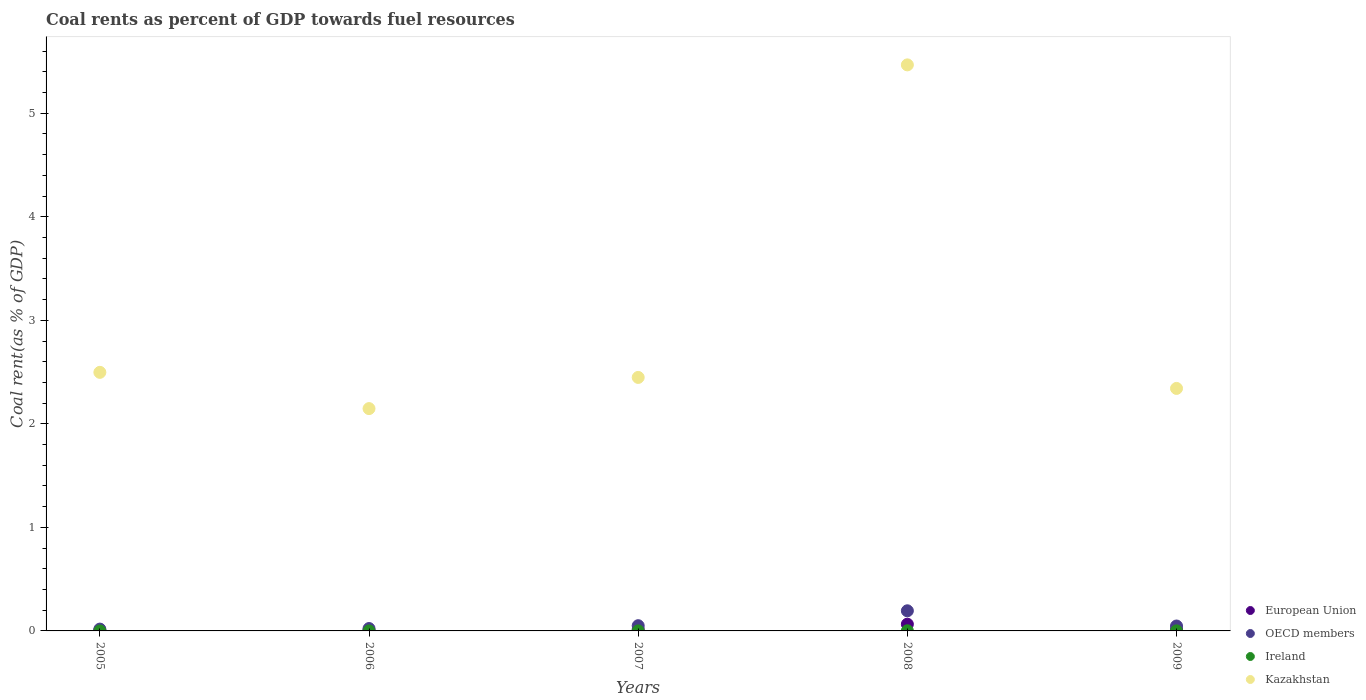What is the coal rent in Kazakhstan in 2007?
Your answer should be very brief. 2.45. Across all years, what is the maximum coal rent in Ireland?
Your response must be concise. 0. Across all years, what is the minimum coal rent in European Union?
Your answer should be very brief. 0.01. What is the total coal rent in Kazakhstan in the graph?
Ensure brevity in your answer.  14.9. What is the difference between the coal rent in European Union in 2006 and that in 2008?
Offer a terse response. -0.06. What is the difference between the coal rent in Ireland in 2005 and the coal rent in OECD members in 2008?
Your answer should be compact. -0.19. What is the average coal rent in European Union per year?
Your answer should be compact. 0.02. In the year 2006, what is the difference between the coal rent in OECD members and coal rent in European Union?
Your response must be concise. 0.02. In how many years, is the coal rent in Ireland greater than 1.8 %?
Provide a short and direct response. 0. What is the ratio of the coal rent in OECD members in 2008 to that in 2009?
Offer a very short reply. 4.09. Is the coal rent in Ireland in 2005 less than that in 2007?
Ensure brevity in your answer.  Yes. What is the difference between the highest and the second highest coal rent in OECD members?
Provide a succinct answer. 0.14. What is the difference between the highest and the lowest coal rent in Ireland?
Provide a short and direct response. 0. Is it the case that in every year, the sum of the coal rent in OECD members and coal rent in Kazakhstan  is greater than the sum of coal rent in European Union and coal rent in Ireland?
Make the answer very short. Yes. Is the coal rent in OECD members strictly greater than the coal rent in Ireland over the years?
Your answer should be compact. Yes. Is the coal rent in OECD members strictly less than the coal rent in Ireland over the years?
Give a very brief answer. No. How many dotlines are there?
Your answer should be compact. 4. What is the difference between two consecutive major ticks on the Y-axis?
Make the answer very short. 1. Are the values on the major ticks of Y-axis written in scientific E-notation?
Keep it short and to the point. No. Does the graph contain any zero values?
Offer a terse response. No. Does the graph contain grids?
Keep it short and to the point. No. How many legend labels are there?
Offer a very short reply. 4. How are the legend labels stacked?
Provide a succinct answer. Vertical. What is the title of the graph?
Ensure brevity in your answer.  Coal rents as percent of GDP towards fuel resources. Does "South Sudan" appear as one of the legend labels in the graph?
Your response must be concise. No. What is the label or title of the Y-axis?
Keep it short and to the point. Coal rent(as % of GDP). What is the Coal rent(as % of GDP) of European Union in 2005?
Make the answer very short. 0.01. What is the Coal rent(as % of GDP) in OECD members in 2005?
Your answer should be very brief. 0.02. What is the Coal rent(as % of GDP) of Ireland in 2005?
Keep it short and to the point. 7.66717495498807e-5. What is the Coal rent(as % of GDP) of Kazakhstan in 2005?
Your answer should be compact. 2.5. What is the Coal rent(as % of GDP) of European Union in 2006?
Your answer should be very brief. 0.01. What is the Coal rent(as % of GDP) in OECD members in 2006?
Make the answer very short. 0.02. What is the Coal rent(as % of GDP) in Ireland in 2006?
Keep it short and to the point. 0. What is the Coal rent(as % of GDP) of Kazakhstan in 2006?
Offer a terse response. 2.15. What is the Coal rent(as % of GDP) of European Union in 2007?
Provide a succinct answer. 0.01. What is the Coal rent(as % of GDP) in OECD members in 2007?
Provide a short and direct response. 0.05. What is the Coal rent(as % of GDP) of Ireland in 2007?
Your response must be concise. 0. What is the Coal rent(as % of GDP) in Kazakhstan in 2007?
Your answer should be compact. 2.45. What is the Coal rent(as % of GDP) in European Union in 2008?
Ensure brevity in your answer.  0.07. What is the Coal rent(as % of GDP) of OECD members in 2008?
Provide a short and direct response. 0.19. What is the Coal rent(as % of GDP) in Ireland in 2008?
Ensure brevity in your answer.  0. What is the Coal rent(as % of GDP) in Kazakhstan in 2008?
Make the answer very short. 5.47. What is the Coal rent(as % of GDP) of European Union in 2009?
Ensure brevity in your answer.  0.01. What is the Coal rent(as % of GDP) of OECD members in 2009?
Offer a very short reply. 0.05. What is the Coal rent(as % of GDP) in Ireland in 2009?
Your response must be concise. 0. What is the Coal rent(as % of GDP) of Kazakhstan in 2009?
Your answer should be very brief. 2.34. Across all years, what is the maximum Coal rent(as % of GDP) of European Union?
Make the answer very short. 0.07. Across all years, what is the maximum Coal rent(as % of GDP) in OECD members?
Offer a terse response. 0.19. Across all years, what is the maximum Coal rent(as % of GDP) in Ireland?
Your answer should be compact. 0. Across all years, what is the maximum Coal rent(as % of GDP) of Kazakhstan?
Your answer should be compact. 5.47. Across all years, what is the minimum Coal rent(as % of GDP) in European Union?
Keep it short and to the point. 0.01. Across all years, what is the minimum Coal rent(as % of GDP) in OECD members?
Keep it short and to the point. 0.02. Across all years, what is the minimum Coal rent(as % of GDP) in Ireland?
Give a very brief answer. 7.66717495498807e-5. Across all years, what is the minimum Coal rent(as % of GDP) of Kazakhstan?
Provide a short and direct response. 2.15. What is the total Coal rent(as % of GDP) of European Union in the graph?
Ensure brevity in your answer.  0.11. What is the total Coal rent(as % of GDP) in OECD members in the graph?
Offer a very short reply. 0.33. What is the total Coal rent(as % of GDP) of Ireland in the graph?
Provide a succinct answer. 0. What is the total Coal rent(as % of GDP) in Kazakhstan in the graph?
Offer a very short reply. 14.9. What is the difference between the Coal rent(as % of GDP) of European Union in 2005 and that in 2006?
Ensure brevity in your answer.  -0. What is the difference between the Coal rent(as % of GDP) of OECD members in 2005 and that in 2006?
Your answer should be compact. -0.01. What is the difference between the Coal rent(as % of GDP) of Ireland in 2005 and that in 2006?
Offer a terse response. -0. What is the difference between the Coal rent(as % of GDP) of Kazakhstan in 2005 and that in 2006?
Offer a very short reply. 0.35. What is the difference between the Coal rent(as % of GDP) of European Union in 2005 and that in 2007?
Provide a succinct answer. -0.01. What is the difference between the Coal rent(as % of GDP) of OECD members in 2005 and that in 2007?
Your answer should be compact. -0.03. What is the difference between the Coal rent(as % of GDP) in Ireland in 2005 and that in 2007?
Your answer should be very brief. -0. What is the difference between the Coal rent(as % of GDP) in Kazakhstan in 2005 and that in 2007?
Provide a short and direct response. 0.05. What is the difference between the Coal rent(as % of GDP) in European Union in 2005 and that in 2008?
Offer a very short reply. -0.06. What is the difference between the Coal rent(as % of GDP) of OECD members in 2005 and that in 2008?
Offer a very short reply. -0.18. What is the difference between the Coal rent(as % of GDP) in Ireland in 2005 and that in 2008?
Your response must be concise. -0. What is the difference between the Coal rent(as % of GDP) in Kazakhstan in 2005 and that in 2008?
Provide a succinct answer. -2.97. What is the difference between the Coal rent(as % of GDP) in European Union in 2005 and that in 2009?
Your answer should be very brief. -0.01. What is the difference between the Coal rent(as % of GDP) of OECD members in 2005 and that in 2009?
Give a very brief answer. -0.03. What is the difference between the Coal rent(as % of GDP) in Ireland in 2005 and that in 2009?
Make the answer very short. -0. What is the difference between the Coal rent(as % of GDP) of Kazakhstan in 2005 and that in 2009?
Offer a very short reply. 0.16. What is the difference between the Coal rent(as % of GDP) in European Union in 2006 and that in 2007?
Give a very brief answer. -0.01. What is the difference between the Coal rent(as % of GDP) of OECD members in 2006 and that in 2007?
Offer a terse response. -0.03. What is the difference between the Coal rent(as % of GDP) of Ireland in 2006 and that in 2007?
Provide a succinct answer. -0. What is the difference between the Coal rent(as % of GDP) in Kazakhstan in 2006 and that in 2007?
Give a very brief answer. -0.3. What is the difference between the Coal rent(as % of GDP) in European Union in 2006 and that in 2008?
Provide a succinct answer. -0.06. What is the difference between the Coal rent(as % of GDP) of OECD members in 2006 and that in 2008?
Make the answer very short. -0.17. What is the difference between the Coal rent(as % of GDP) of Ireland in 2006 and that in 2008?
Your answer should be compact. -0. What is the difference between the Coal rent(as % of GDP) in Kazakhstan in 2006 and that in 2008?
Offer a very short reply. -3.32. What is the difference between the Coal rent(as % of GDP) in European Union in 2006 and that in 2009?
Keep it short and to the point. -0.01. What is the difference between the Coal rent(as % of GDP) in OECD members in 2006 and that in 2009?
Your answer should be compact. -0.02. What is the difference between the Coal rent(as % of GDP) of Ireland in 2006 and that in 2009?
Your answer should be very brief. -0. What is the difference between the Coal rent(as % of GDP) of Kazakhstan in 2006 and that in 2009?
Your response must be concise. -0.19. What is the difference between the Coal rent(as % of GDP) of European Union in 2007 and that in 2008?
Give a very brief answer. -0.05. What is the difference between the Coal rent(as % of GDP) of OECD members in 2007 and that in 2008?
Your answer should be very brief. -0.14. What is the difference between the Coal rent(as % of GDP) of Ireland in 2007 and that in 2008?
Ensure brevity in your answer.  -0. What is the difference between the Coal rent(as % of GDP) in Kazakhstan in 2007 and that in 2008?
Your answer should be compact. -3.02. What is the difference between the Coal rent(as % of GDP) of European Union in 2007 and that in 2009?
Provide a short and direct response. 0. What is the difference between the Coal rent(as % of GDP) of OECD members in 2007 and that in 2009?
Provide a short and direct response. 0. What is the difference between the Coal rent(as % of GDP) of Ireland in 2007 and that in 2009?
Make the answer very short. -0. What is the difference between the Coal rent(as % of GDP) of Kazakhstan in 2007 and that in 2009?
Provide a succinct answer. 0.11. What is the difference between the Coal rent(as % of GDP) in European Union in 2008 and that in 2009?
Make the answer very short. 0.05. What is the difference between the Coal rent(as % of GDP) in OECD members in 2008 and that in 2009?
Offer a very short reply. 0.15. What is the difference between the Coal rent(as % of GDP) in Ireland in 2008 and that in 2009?
Offer a very short reply. 0. What is the difference between the Coal rent(as % of GDP) in Kazakhstan in 2008 and that in 2009?
Offer a terse response. 3.12. What is the difference between the Coal rent(as % of GDP) of European Union in 2005 and the Coal rent(as % of GDP) of OECD members in 2006?
Offer a terse response. -0.02. What is the difference between the Coal rent(as % of GDP) in European Union in 2005 and the Coal rent(as % of GDP) in Ireland in 2006?
Keep it short and to the point. 0.01. What is the difference between the Coal rent(as % of GDP) in European Union in 2005 and the Coal rent(as % of GDP) in Kazakhstan in 2006?
Keep it short and to the point. -2.14. What is the difference between the Coal rent(as % of GDP) in OECD members in 2005 and the Coal rent(as % of GDP) in Ireland in 2006?
Your response must be concise. 0.02. What is the difference between the Coal rent(as % of GDP) of OECD members in 2005 and the Coal rent(as % of GDP) of Kazakhstan in 2006?
Your answer should be compact. -2.13. What is the difference between the Coal rent(as % of GDP) of Ireland in 2005 and the Coal rent(as % of GDP) of Kazakhstan in 2006?
Offer a very short reply. -2.15. What is the difference between the Coal rent(as % of GDP) in European Union in 2005 and the Coal rent(as % of GDP) in OECD members in 2007?
Provide a succinct answer. -0.04. What is the difference between the Coal rent(as % of GDP) of European Union in 2005 and the Coal rent(as % of GDP) of Ireland in 2007?
Provide a short and direct response. 0.01. What is the difference between the Coal rent(as % of GDP) in European Union in 2005 and the Coal rent(as % of GDP) in Kazakhstan in 2007?
Keep it short and to the point. -2.44. What is the difference between the Coal rent(as % of GDP) in OECD members in 2005 and the Coal rent(as % of GDP) in Ireland in 2007?
Provide a short and direct response. 0.02. What is the difference between the Coal rent(as % of GDP) of OECD members in 2005 and the Coal rent(as % of GDP) of Kazakhstan in 2007?
Offer a very short reply. -2.43. What is the difference between the Coal rent(as % of GDP) in Ireland in 2005 and the Coal rent(as % of GDP) in Kazakhstan in 2007?
Your answer should be compact. -2.45. What is the difference between the Coal rent(as % of GDP) of European Union in 2005 and the Coal rent(as % of GDP) of OECD members in 2008?
Your answer should be very brief. -0.19. What is the difference between the Coal rent(as % of GDP) of European Union in 2005 and the Coal rent(as % of GDP) of Ireland in 2008?
Offer a very short reply. 0.01. What is the difference between the Coal rent(as % of GDP) of European Union in 2005 and the Coal rent(as % of GDP) of Kazakhstan in 2008?
Keep it short and to the point. -5.46. What is the difference between the Coal rent(as % of GDP) of OECD members in 2005 and the Coal rent(as % of GDP) of Ireland in 2008?
Keep it short and to the point. 0.02. What is the difference between the Coal rent(as % of GDP) in OECD members in 2005 and the Coal rent(as % of GDP) in Kazakhstan in 2008?
Offer a very short reply. -5.45. What is the difference between the Coal rent(as % of GDP) of Ireland in 2005 and the Coal rent(as % of GDP) of Kazakhstan in 2008?
Your response must be concise. -5.47. What is the difference between the Coal rent(as % of GDP) of European Union in 2005 and the Coal rent(as % of GDP) of OECD members in 2009?
Offer a very short reply. -0.04. What is the difference between the Coal rent(as % of GDP) of European Union in 2005 and the Coal rent(as % of GDP) of Ireland in 2009?
Your answer should be very brief. 0.01. What is the difference between the Coal rent(as % of GDP) in European Union in 2005 and the Coal rent(as % of GDP) in Kazakhstan in 2009?
Offer a terse response. -2.34. What is the difference between the Coal rent(as % of GDP) of OECD members in 2005 and the Coal rent(as % of GDP) of Ireland in 2009?
Provide a short and direct response. 0.02. What is the difference between the Coal rent(as % of GDP) in OECD members in 2005 and the Coal rent(as % of GDP) in Kazakhstan in 2009?
Your answer should be compact. -2.32. What is the difference between the Coal rent(as % of GDP) in Ireland in 2005 and the Coal rent(as % of GDP) in Kazakhstan in 2009?
Provide a succinct answer. -2.34. What is the difference between the Coal rent(as % of GDP) of European Union in 2006 and the Coal rent(as % of GDP) of OECD members in 2007?
Make the answer very short. -0.04. What is the difference between the Coal rent(as % of GDP) in European Union in 2006 and the Coal rent(as % of GDP) in Ireland in 2007?
Ensure brevity in your answer.  0.01. What is the difference between the Coal rent(as % of GDP) of European Union in 2006 and the Coal rent(as % of GDP) of Kazakhstan in 2007?
Your answer should be compact. -2.44. What is the difference between the Coal rent(as % of GDP) in OECD members in 2006 and the Coal rent(as % of GDP) in Ireland in 2007?
Give a very brief answer. 0.02. What is the difference between the Coal rent(as % of GDP) in OECD members in 2006 and the Coal rent(as % of GDP) in Kazakhstan in 2007?
Offer a terse response. -2.43. What is the difference between the Coal rent(as % of GDP) in Ireland in 2006 and the Coal rent(as % of GDP) in Kazakhstan in 2007?
Your answer should be very brief. -2.45. What is the difference between the Coal rent(as % of GDP) of European Union in 2006 and the Coal rent(as % of GDP) of OECD members in 2008?
Your answer should be compact. -0.19. What is the difference between the Coal rent(as % of GDP) in European Union in 2006 and the Coal rent(as % of GDP) in Ireland in 2008?
Offer a terse response. 0.01. What is the difference between the Coal rent(as % of GDP) in European Union in 2006 and the Coal rent(as % of GDP) in Kazakhstan in 2008?
Your response must be concise. -5.46. What is the difference between the Coal rent(as % of GDP) in OECD members in 2006 and the Coal rent(as % of GDP) in Ireland in 2008?
Your answer should be compact. 0.02. What is the difference between the Coal rent(as % of GDP) of OECD members in 2006 and the Coal rent(as % of GDP) of Kazakhstan in 2008?
Ensure brevity in your answer.  -5.44. What is the difference between the Coal rent(as % of GDP) in Ireland in 2006 and the Coal rent(as % of GDP) in Kazakhstan in 2008?
Your response must be concise. -5.47. What is the difference between the Coal rent(as % of GDP) of European Union in 2006 and the Coal rent(as % of GDP) of OECD members in 2009?
Offer a terse response. -0.04. What is the difference between the Coal rent(as % of GDP) in European Union in 2006 and the Coal rent(as % of GDP) in Ireland in 2009?
Offer a very short reply. 0.01. What is the difference between the Coal rent(as % of GDP) in European Union in 2006 and the Coal rent(as % of GDP) in Kazakhstan in 2009?
Provide a succinct answer. -2.33. What is the difference between the Coal rent(as % of GDP) of OECD members in 2006 and the Coal rent(as % of GDP) of Ireland in 2009?
Provide a short and direct response. 0.02. What is the difference between the Coal rent(as % of GDP) in OECD members in 2006 and the Coal rent(as % of GDP) in Kazakhstan in 2009?
Offer a terse response. -2.32. What is the difference between the Coal rent(as % of GDP) in Ireland in 2006 and the Coal rent(as % of GDP) in Kazakhstan in 2009?
Your answer should be compact. -2.34. What is the difference between the Coal rent(as % of GDP) in European Union in 2007 and the Coal rent(as % of GDP) in OECD members in 2008?
Offer a terse response. -0.18. What is the difference between the Coal rent(as % of GDP) of European Union in 2007 and the Coal rent(as % of GDP) of Ireland in 2008?
Give a very brief answer. 0.01. What is the difference between the Coal rent(as % of GDP) in European Union in 2007 and the Coal rent(as % of GDP) in Kazakhstan in 2008?
Provide a succinct answer. -5.45. What is the difference between the Coal rent(as % of GDP) in OECD members in 2007 and the Coal rent(as % of GDP) in Ireland in 2008?
Your response must be concise. 0.05. What is the difference between the Coal rent(as % of GDP) in OECD members in 2007 and the Coal rent(as % of GDP) in Kazakhstan in 2008?
Your answer should be very brief. -5.42. What is the difference between the Coal rent(as % of GDP) of Ireland in 2007 and the Coal rent(as % of GDP) of Kazakhstan in 2008?
Ensure brevity in your answer.  -5.47. What is the difference between the Coal rent(as % of GDP) of European Union in 2007 and the Coal rent(as % of GDP) of OECD members in 2009?
Your answer should be very brief. -0.03. What is the difference between the Coal rent(as % of GDP) of European Union in 2007 and the Coal rent(as % of GDP) of Ireland in 2009?
Keep it short and to the point. 0.01. What is the difference between the Coal rent(as % of GDP) in European Union in 2007 and the Coal rent(as % of GDP) in Kazakhstan in 2009?
Provide a short and direct response. -2.33. What is the difference between the Coal rent(as % of GDP) of OECD members in 2007 and the Coal rent(as % of GDP) of Ireland in 2009?
Give a very brief answer. 0.05. What is the difference between the Coal rent(as % of GDP) of OECD members in 2007 and the Coal rent(as % of GDP) of Kazakhstan in 2009?
Provide a succinct answer. -2.29. What is the difference between the Coal rent(as % of GDP) of Ireland in 2007 and the Coal rent(as % of GDP) of Kazakhstan in 2009?
Make the answer very short. -2.34. What is the difference between the Coal rent(as % of GDP) of European Union in 2008 and the Coal rent(as % of GDP) of OECD members in 2009?
Offer a terse response. 0.02. What is the difference between the Coal rent(as % of GDP) of European Union in 2008 and the Coal rent(as % of GDP) of Ireland in 2009?
Make the answer very short. 0.06. What is the difference between the Coal rent(as % of GDP) of European Union in 2008 and the Coal rent(as % of GDP) of Kazakhstan in 2009?
Offer a very short reply. -2.28. What is the difference between the Coal rent(as % of GDP) of OECD members in 2008 and the Coal rent(as % of GDP) of Ireland in 2009?
Offer a very short reply. 0.19. What is the difference between the Coal rent(as % of GDP) of OECD members in 2008 and the Coal rent(as % of GDP) of Kazakhstan in 2009?
Your response must be concise. -2.15. What is the difference between the Coal rent(as % of GDP) of Ireland in 2008 and the Coal rent(as % of GDP) of Kazakhstan in 2009?
Keep it short and to the point. -2.34. What is the average Coal rent(as % of GDP) in European Union per year?
Your response must be concise. 0.02. What is the average Coal rent(as % of GDP) in OECD members per year?
Offer a very short reply. 0.07. What is the average Coal rent(as % of GDP) of Ireland per year?
Give a very brief answer. 0. What is the average Coal rent(as % of GDP) in Kazakhstan per year?
Offer a very short reply. 2.98. In the year 2005, what is the difference between the Coal rent(as % of GDP) of European Union and Coal rent(as % of GDP) of OECD members?
Provide a succinct answer. -0.01. In the year 2005, what is the difference between the Coal rent(as % of GDP) of European Union and Coal rent(as % of GDP) of Ireland?
Your response must be concise. 0.01. In the year 2005, what is the difference between the Coal rent(as % of GDP) of European Union and Coal rent(as % of GDP) of Kazakhstan?
Offer a terse response. -2.49. In the year 2005, what is the difference between the Coal rent(as % of GDP) in OECD members and Coal rent(as % of GDP) in Ireland?
Your answer should be compact. 0.02. In the year 2005, what is the difference between the Coal rent(as % of GDP) of OECD members and Coal rent(as % of GDP) of Kazakhstan?
Provide a short and direct response. -2.48. In the year 2005, what is the difference between the Coal rent(as % of GDP) in Ireland and Coal rent(as % of GDP) in Kazakhstan?
Your answer should be compact. -2.5. In the year 2006, what is the difference between the Coal rent(as % of GDP) in European Union and Coal rent(as % of GDP) in OECD members?
Provide a short and direct response. -0.02. In the year 2006, what is the difference between the Coal rent(as % of GDP) in European Union and Coal rent(as % of GDP) in Ireland?
Make the answer very short. 0.01. In the year 2006, what is the difference between the Coal rent(as % of GDP) in European Union and Coal rent(as % of GDP) in Kazakhstan?
Your response must be concise. -2.14. In the year 2006, what is the difference between the Coal rent(as % of GDP) in OECD members and Coal rent(as % of GDP) in Ireland?
Offer a terse response. 0.02. In the year 2006, what is the difference between the Coal rent(as % of GDP) of OECD members and Coal rent(as % of GDP) of Kazakhstan?
Give a very brief answer. -2.12. In the year 2006, what is the difference between the Coal rent(as % of GDP) in Ireland and Coal rent(as % of GDP) in Kazakhstan?
Provide a short and direct response. -2.15. In the year 2007, what is the difference between the Coal rent(as % of GDP) in European Union and Coal rent(as % of GDP) in OECD members?
Provide a short and direct response. -0.04. In the year 2007, what is the difference between the Coal rent(as % of GDP) in European Union and Coal rent(as % of GDP) in Ireland?
Give a very brief answer. 0.01. In the year 2007, what is the difference between the Coal rent(as % of GDP) in European Union and Coal rent(as % of GDP) in Kazakhstan?
Your answer should be compact. -2.43. In the year 2007, what is the difference between the Coal rent(as % of GDP) in OECD members and Coal rent(as % of GDP) in Ireland?
Offer a very short reply. 0.05. In the year 2007, what is the difference between the Coal rent(as % of GDP) in OECD members and Coal rent(as % of GDP) in Kazakhstan?
Give a very brief answer. -2.4. In the year 2007, what is the difference between the Coal rent(as % of GDP) of Ireland and Coal rent(as % of GDP) of Kazakhstan?
Offer a terse response. -2.45. In the year 2008, what is the difference between the Coal rent(as % of GDP) in European Union and Coal rent(as % of GDP) in OECD members?
Your answer should be very brief. -0.13. In the year 2008, what is the difference between the Coal rent(as % of GDP) in European Union and Coal rent(as % of GDP) in Ireland?
Your response must be concise. 0.06. In the year 2008, what is the difference between the Coal rent(as % of GDP) in European Union and Coal rent(as % of GDP) in Kazakhstan?
Your response must be concise. -5.4. In the year 2008, what is the difference between the Coal rent(as % of GDP) in OECD members and Coal rent(as % of GDP) in Ireland?
Your response must be concise. 0.19. In the year 2008, what is the difference between the Coal rent(as % of GDP) in OECD members and Coal rent(as % of GDP) in Kazakhstan?
Keep it short and to the point. -5.27. In the year 2008, what is the difference between the Coal rent(as % of GDP) of Ireland and Coal rent(as % of GDP) of Kazakhstan?
Make the answer very short. -5.47. In the year 2009, what is the difference between the Coal rent(as % of GDP) of European Union and Coal rent(as % of GDP) of OECD members?
Offer a very short reply. -0.03. In the year 2009, what is the difference between the Coal rent(as % of GDP) in European Union and Coal rent(as % of GDP) in Ireland?
Your answer should be very brief. 0.01. In the year 2009, what is the difference between the Coal rent(as % of GDP) of European Union and Coal rent(as % of GDP) of Kazakhstan?
Your answer should be very brief. -2.33. In the year 2009, what is the difference between the Coal rent(as % of GDP) of OECD members and Coal rent(as % of GDP) of Ireland?
Your answer should be compact. 0.05. In the year 2009, what is the difference between the Coal rent(as % of GDP) of OECD members and Coal rent(as % of GDP) of Kazakhstan?
Offer a very short reply. -2.29. In the year 2009, what is the difference between the Coal rent(as % of GDP) in Ireland and Coal rent(as % of GDP) in Kazakhstan?
Ensure brevity in your answer.  -2.34. What is the ratio of the Coal rent(as % of GDP) in European Union in 2005 to that in 2006?
Make the answer very short. 0.86. What is the ratio of the Coal rent(as % of GDP) in OECD members in 2005 to that in 2006?
Your answer should be very brief. 0.77. What is the ratio of the Coal rent(as % of GDP) of Ireland in 2005 to that in 2006?
Your response must be concise. 0.67. What is the ratio of the Coal rent(as % of GDP) in Kazakhstan in 2005 to that in 2006?
Keep it short and to the point. 1.16. What is the ratio of the Coal rent(as % of GDP) of European Union in 2005 to that in 2007?
Provide a short and direct response. 0.43. What is the ratio of the Coal rent(as % of GDP) in OECD members in 2005 to that in 2007?
Give a very brief answer. 0.35. What is the ratio of the Coal rent(as % of GDP) of Ireland in 2005 to that in 2007?
Offer a very short reply. 0.25. What is the ratio of the Coal rent(as % of GDP) of European Union in 2005 to that in 2008?
Offer a very short reply. 0.1. What is the ratio of the Coal rent(as % of GDP) in OECD members in 2005 to that in 2008?
Make the answer very short. 0.09. What is the ratio of the Coal rent(as % of GDP) of Ireland in 2005 to that in 2008?
Make the answer very short. 0.05. What is the ratio of the Coal rent(as % of GDP) in Kazakhstan in 2005 to that in 2008?
Offer a very short reply. 0.46. What is the ratio of the Coal rent(as % of GDP) in European Union in 2005 to that in 2009?
Offer a very short reply. 0.47. What is the ratio of the Coal rent(as % of GDP) in OECD members in 2005 to that in 2009?
Your response must be concise. 0.37. What is the ratio of the Coal rent(as % of GDP) in Ireland in 2005 to that in 2009?
Keep it short and to the point. 0.16. What is the ratio of the Coal rent(as % of GDP) in Kazakhstan in 2005 to that in 2009?
Ensure brevity in your answer.  1.07. What is the ratio of the Coal rent(as % of GDP) of European Union in 2006 to that in 2007?
Make the answer very short. 0.51. What is the ratio of the Coal rent(as % of GDP) of OECD members in 2006 to that in 2007?
Keep it short and to the point. 0.46. What is the ratio of the Coal rent(as % of GDP) of Ireland in 2006 to that in 2007?
Your answer should be very brief. 0.37. What is the ratio of the Coal rent(as % of GDP) in Kazakhstan in 2006 to that in 2007?
Give a very brief answer. 0.88. What is the ratio of the Coal rent(as % of GDP) in European Union in 2006 to that in 2008?
Ensure brevity in your answer.  0.12. What is the ratio of the Coal rent(as % of GDP) in OECD members in 2006 to that in 2008?
Give a very brief answer. 0.12. What is the ratio of the Coal rent(as % of GDP) of Ireland in 2006 to that in 2008?
Your answer should be compact. 0.07. What is the ratio of the Coal rent(as % of GDP) in Kazakhstan in 2006 to that in 2008?
Offer a terse response. 0.39. What is the ratio of the Coal rent(as % of GDP) of European Union in 2006 to that in 2009?
Keep it short and to the point. 0.55. What is the ratio of the Coal rent(as % of GDP) in OECD members in 2006 to that in 2009?
Offer a very short reply. 0.48. What is the ratio of the Coal rent(as % of GDP) in Ireland in 2006 to that in 2009?
Keep it short and to the point. 0.23. What is the ratio of the Coal rent(as % of GDP) of Kazakhstan in 2006 to that in 2009?
Provide a succinct answer. 0.92. What is the ratio of the Coal rent(as % of GDP) of European Union in 2007 to that in 2008?
Ensure brevity in your answer.  0.23. What is the ratio of the Coal rent(as % of GDP) of OECD members in 2007 to that in 2008?
Your response must be concise. 0.26. What is the ratio of the Coal rent(as % of GDP) in Ireland in 2007 to that in 2008?
Make the answer very short. 0.2. What is the ratio of the Coal rent(as % of GDP) of Kazakhstan in 2007 to that in 2008?
Your answer should be very brief. 0.45. What is the ratio of the Coal rent(as % of GDP) in European Union in 2007 to that in 2009?
Ensure brevity in your answer.  1.09. What is the ratio of the Coal rent(as % of GDP) of OECD members in 2007 to that in 2009?
Your response must be concise. 1.06. What is the ratio of the Coal rent(as % of GDP) of Ireland in 2007 to that in 2009?
Ensure brevity in your answer.  0.63. What is the ratio of the Coal rent(as % of GDP) in Kazakhstan in 2007 to that in 2009?
Ensure brevity in your answer.  1.05. What is the ratio of the Coal rent(as % of GDP) of European Union in 2008 to that in 2009?
Offer a very short reply. 4.73. What is the ratio of the Coal rent(as % of GDP) of OECD members in 2008 to that in 2009?
Keep it short and to the point. 4.09. What is the ratio of the Coal rent(as % of GDP) in Ireland in 2008 to that in 2009?
Keep it short and to the point. 3.12. What is the ratio of the Coal rent(as % of GDP) in Kazakhstan in 2008 to that in 2009?
Ensure brevity in your answer.  2.33. What is the difference between the highest and the second highest Coal rent(as % of GDP) of European Union?
Offer a terse response. 0.05. What is the difference between the highest and the second highest Coal rent(as % of GDP) in OECD members?
Provide a succinct answer. 0.14. What is the difference between the highest and the second highest Coal rent(as % of GDP) in Kazakhstan?
Provide a short and direct response. 2.97. What is the difference between the highest and the lowest Coal rent(as % of GDP) in European Union?
Offer a terse response. 0.06. What is the difference between the highest and the lowest Coal rent(as % of GDP) in OECD members?
Offer a very short reply. 0.18. What is the difference between the highest and the lowest Coal rent(as % of GDP) of Ireland?
Offer a terse response. 0. What is the difference between the highest and the lowest Coal rent(as % of GDP) in Kazakhstan?
Provide a succinct answer. 3.32. 